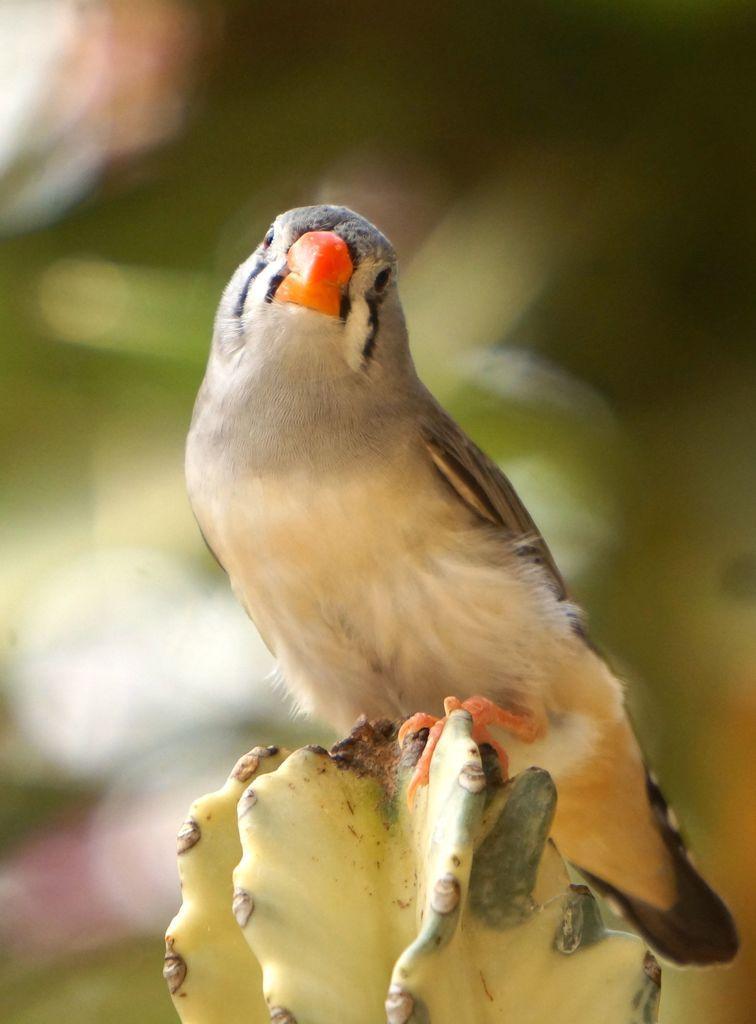How would you summarize this image in a sentence or two? In this image a bird is standing on the cactus plant. Background is blurry. This bird is having orange colour beak. 